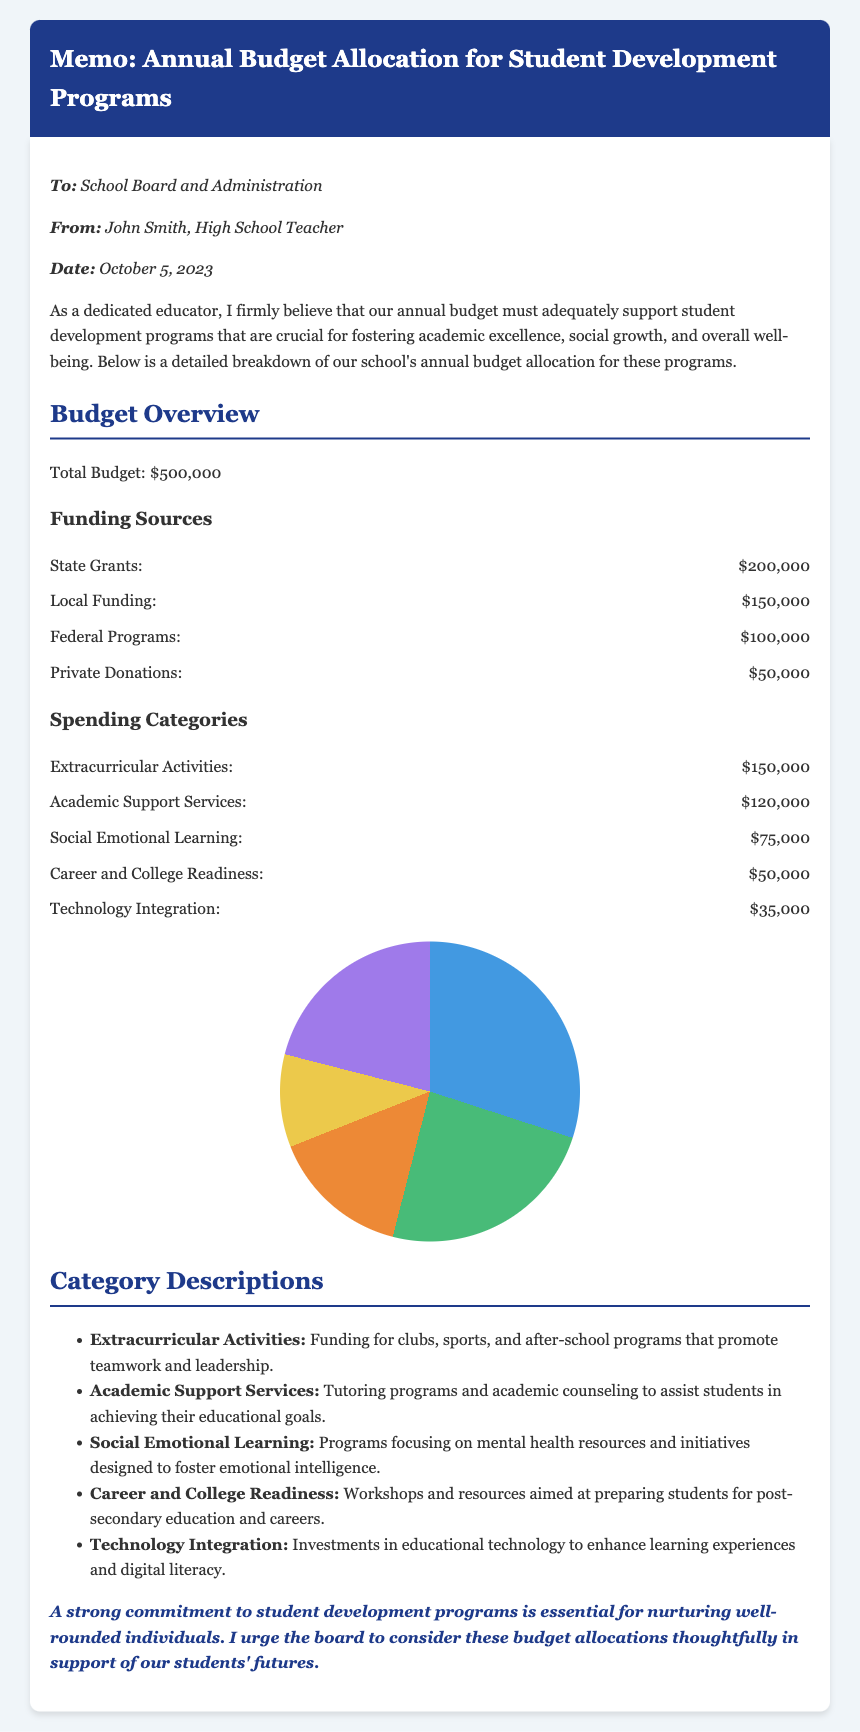What is the total budget? The total budget is explicitly mentioned in the document as $500,000.
Answer: $500,000 How much funding comes from state grants? The amount received from state grants is specifically listed as $200,000.
Answer: $200,000 What is the allocation for social emotional learning? The document states that social emotional learning receives $75,000.
Answer: $75,000 What is the largest source of funding? The largest funding source as per the document is state grants, which amount to $200,000.
Answer: State Grants Which spending category receives the least funding? The spending category mentioned with the least funding is technology integration, receiving $35,000.
Answer: Technology Integration What purpose does the career and college readiness funding serve? The document describes this funding as aimed at preparing students for post-secondary education and careers.
Answer: Preparing students for post-secondary education and careers How many spending categories are listed in the document? The document lists five spending categories under the budget allocation.
Answer: Five Who is the memo addressed to? The memo states it is addressed to the school board and administration.
Answer: School Board and Administration What date was the memo written? The date mentioned in the memo is October 5, 2023.
Answer: October 5, 2023 